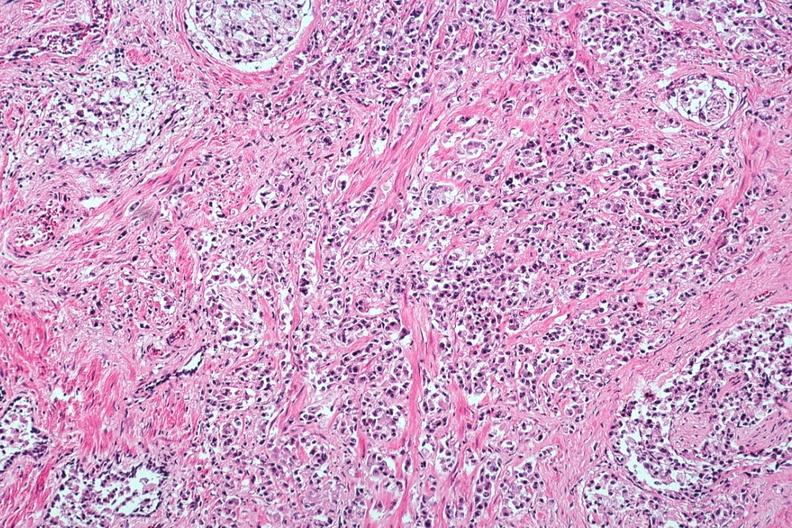what is present?
Answer the question using a single word or phrase. Adenocarcinoma 